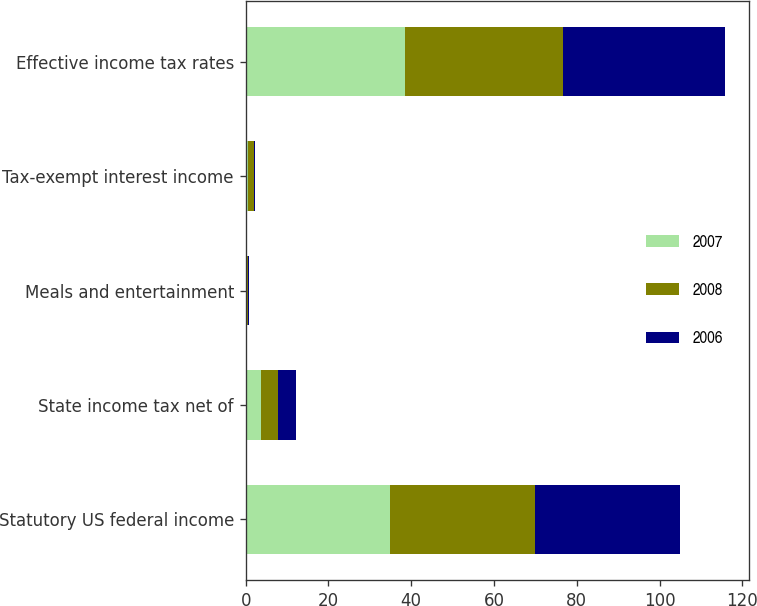Convert chart. <chart><loc_0><loc_0><loc_500><loc_500><stacked_bar_chart><ecel><fcel>Statutory US federal income<fcel>State income tax net of<fcel>Meals and entertainment<fcel>Tax-exempt interest income<fcel>Effective income tax rates<nl><fcel>2007<fcel>35<fcel>3.7<fcel>0.3<fcel>0.5<fcel>38.5<nl><fcel>2008<fcel>35<fcel>4.2<fcel>0.3<fcel>1.5<fcel>38.1<nl><fcel>2006<fcel>35<fcel>4.3<fcel>0.2<fcel>0.2<fcel>39.3<nl></chart> 